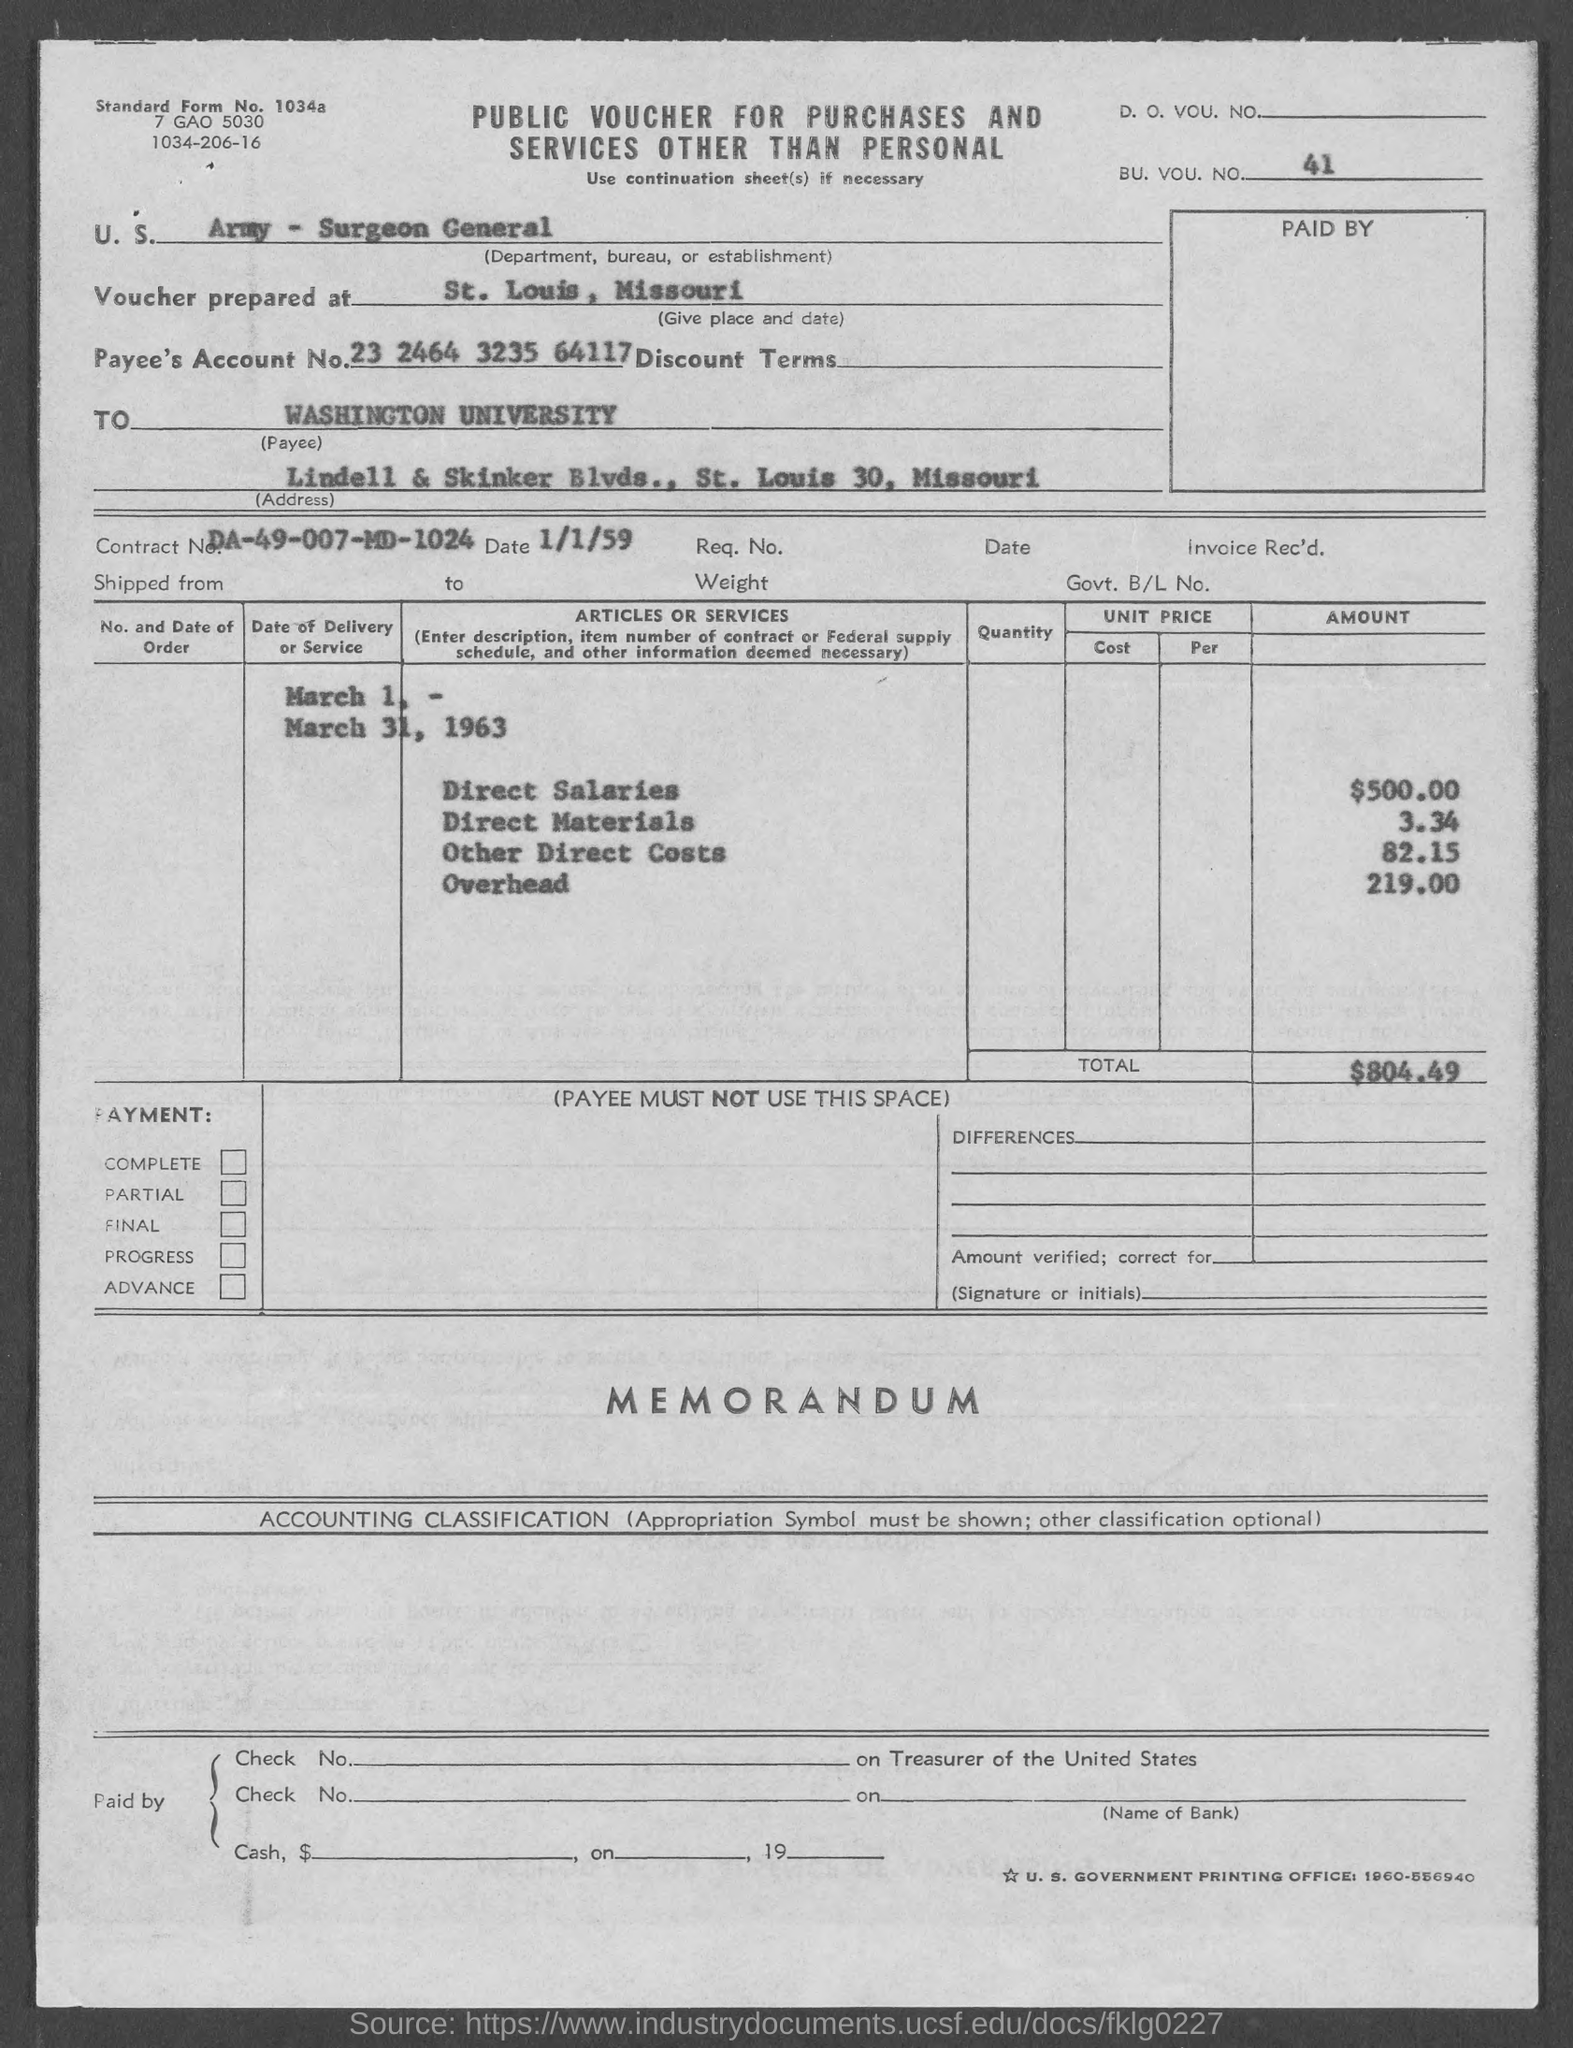What is the Standard Form No. given in the voucher?
Ensure brevity in your answer.  Standard Form No. 1034a. What type of voucher is given here?
Ensure brevity in your answer.  Public Voucher for Purchases and Services Other Than Personal. What is the BU. VOU. NO. mentioned in the voucher?
Ensure brevity in your answer.  41. What is the Department, Bureau, or Establishment mentioned in the voucher?
Ensure brevity in your answer.  U. S. Army - Surgeon General. Where is the voucher prepared at?
Make the answer very short. St. Louis, Missouri. What is the Payee's Account No. given in the voucher?
Ensure brevity in your answer.  23 2464 3235 64117. What is the Contract No. given in the voucher?
Provide a succinct answer. DA-49-007-MD-1024. What is the direct salaries cost mentioned in the voucher?
Your answer should be very brief. $500.00. What is the overhead cost given in the voucher?
Keep it short and to the point. 219.00. What is the total amount mentioned in the voucher?
Your response must be concise. $804.49. 